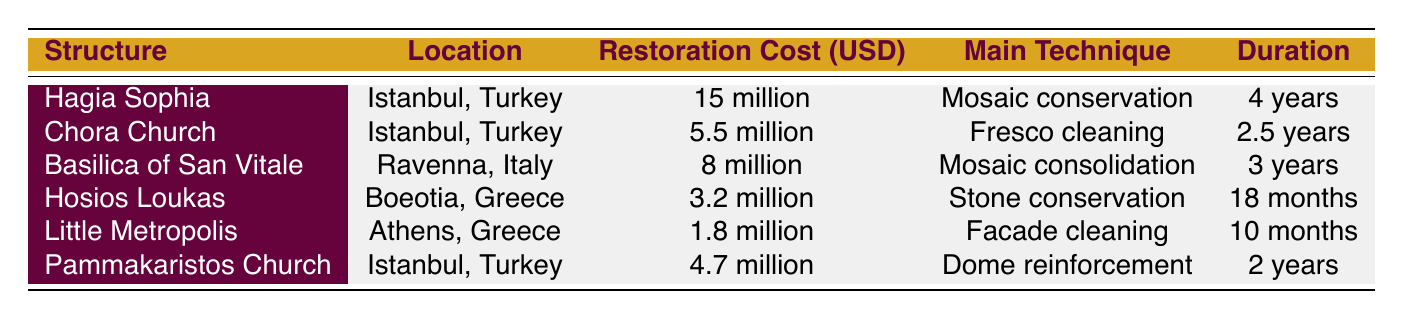What is the restoration cost of the Hagia Sophia? The restoration cost of the Hagia Sophia is clearly listed in the table under the relevant column. Referring to that information points out the cost directly as "15 million".
Answer: 15 million How long did the restoration of the Little Metropolis take? The duration of the restoration for the Little Metropolis is stated in the table. By looking up this specific structure, we find the duration listed as "10 months".
Answer: 10 months Which structure has the highest restoration cost? To find the structure with the highest restoration cost, we review the "Restoration Cost (USD)" column and identify the maximum value. The Hagia Sophia shows the highest cost at "15 million".
Answer: Hagia Sophia What is the average restoration cost of the structures in Turkey? To calculate the average restoration cost of the structures located in Turkey, we first identify their costs: Hagia Sophia (15 million), Chora Church (5.5 million), and Pammakaristos Church (4.7 million). Summing these costs gives us 25.2 million. There are three buildings, so the average is calculated as 25.2 million divided by 3, resulting in approximately 8.4 million.
Answer: 8.4 million Is fresco cleaning the main restoration technique for any of the structures? The main restoration technique for each structure can be verified in the table. By checking the "Main Technique" column, we see that Chora Church uses "Fresco cleaning". This confirms that the answer is "yes".
Answer: Yes Which structure faced challenges related to seismic reinforcement? To find which structure faced challenges related to seismic reinforcement, we look under the "Challenges" column for each structure. The table indicates that Hosios Loukas experienced this specific challenge.
Answer: Hosios Loukas What materials were used in the restoration of the Basilica of San Vitale? The materials used for the Basilica of San Vitale are listed in the "Materials Used" column. Directly referencing that, we see the materials are "Glass tesserae, mortar".
Answer: Glass tesserae, mortar How does the restoration duration of Chora Church compare to that of Pammakaristos Church? To compare the restoration durations, we look at both structures. Chora Church took "2.5 years" while Pammakaristos Church took "2 years". Since 2.5 years is longer than 2 years, we conclude that Chora Church had a longer restoration time.
Answer: Chora Church took longer 